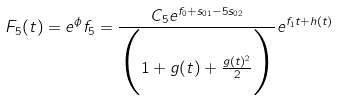<formula> <loc_0><loc_0><loc_500><loc_500>F _ { 5 } ( t ) = e ^ { \phi } f _ { 5 } = \frac { C _ { 5 } e ^ { f _ { 0 } + s _ { 0 1 } - 5 s _ { 0 2 } } } { \Big { ( } 1 + g ( t ) + \frac { g ( t ) ^ { 2 } } { 2 } \Big { ) } } e ^ { f _ { 1 } t + h ( t ) }</formula> 